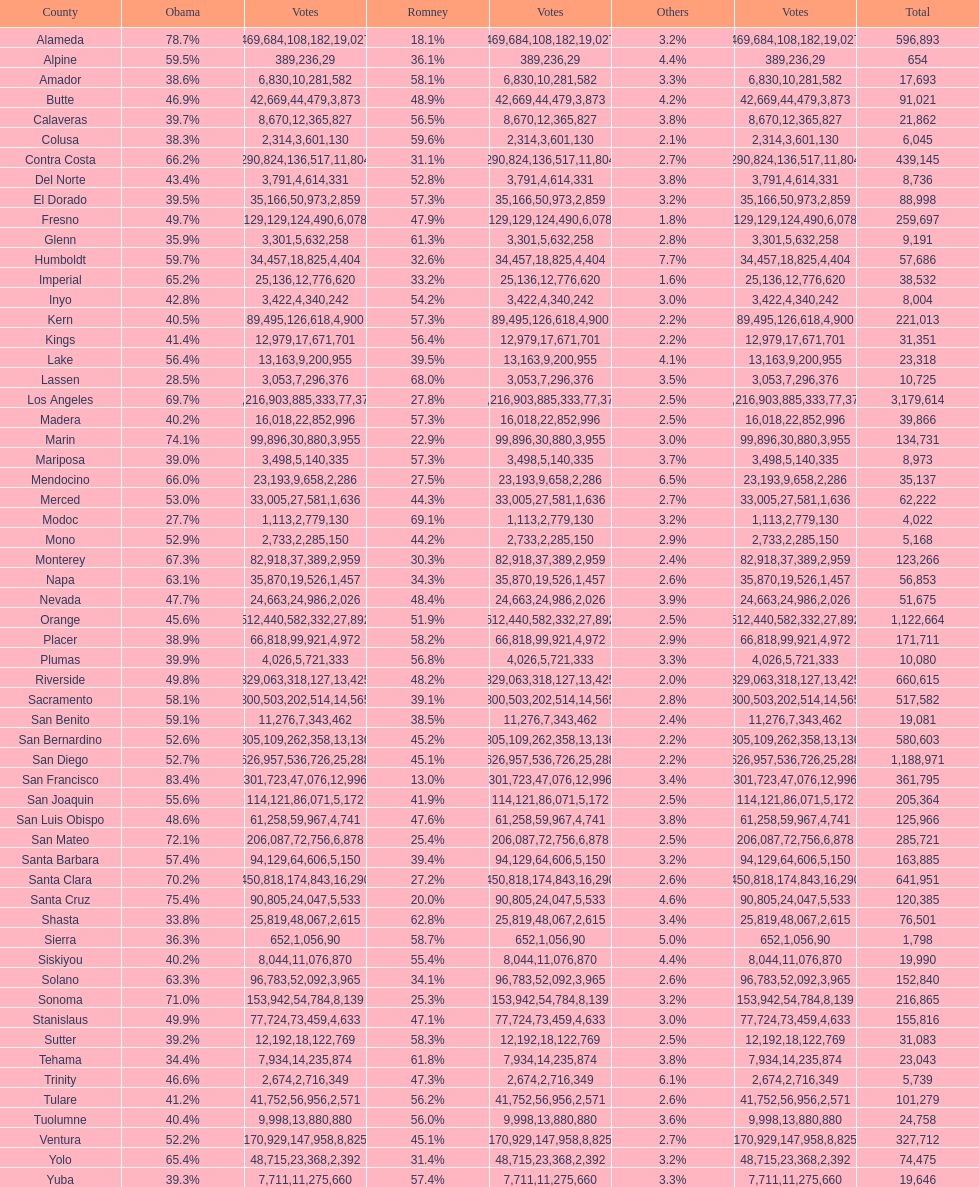What county is just before del norte on the list? Contra Costa. Would you be able to parse every entry in this table? {'header': ['County', 'Obama', 'Votes', 'Romney', 'Votes', 'Others', 'Votes', 'Total'], 'rows': [['Alameda', '78.7%', '469,684', '18.1%', '108,182', '3.2%', '19,027', '596,893'], ['Alpine', '59.5%', '389', '36.1%', '236', '4.4%', '29', '654'], ['Amador', '38.6%', '6,830', '58.1%', '10,281', '3.3%', '582', '17,693'], ['Butte', '46.9%', '42,669', '48.9%', '44,479', '4.2%', '3,873', '91,021'], ['Calaveras', '39.7%', '8,670', '56.5%', '12,365', '3.8%', '827', '21,862'], ['Colusa', '38.3%', '2,314', '59.6%', '3,601', '2.1%', '130', '6,045'], ['Contra Costa', '66.2%', '290,824', '31.1%', '136,517', '2.7%', '11,804', '439,145'], ['Del Norte', '43.4%', '3,791', '52.8%', '4,614', '3.8%', '331', '8,736'], ['El Dorado', '39.5%', '35,166', '57.3%', '50,973', '3.2%', '2,859', '88,998'], ['Fresno', '49.7%', '129,129', '47.9%', '124,490', '1.8%', '6,078', '259,697'], ['Glenn', '35.9%', '3,301', '61.3%', '5,632', '2.8%', '258', '9,191'], ['Humboldt', '59.7%', '34,457', '32.6%', '18,825', '7.7%', '4,404', '57,686'], ['Imperial', '65.2%', '25,136', '33.2%', '12,776', '1.6%', '620', '38,532'], ['Inyo', '42.8%', '3,422', '54.2%', '4,340', '3.0%', '242', '8,004'], ['Kern', '40.5%', '89,495', '57.3%', '126,618', '2.2%', '4,900', '221,013'], ['Kings', '41.4%', '12,979', '56.4%', '17,671', '2.2%', '701', '31,351'], ['Lake', '56.4%', '13,163', '39.5%', '9,200', '4.1%', '955', '23,318'], ['Lassen', '28.5%', '3,053', '68.0%', '7,296', '3.5%', '376', '10,725'], ['Los Angeles', '69.7%', '2,216,903', '27.8%', '885,333', '2.5%', '77,378', '3,179,614'], ['Madera', '40.2%', '16,018', '57.3%', '22,852', '2.5%', '996', '39,866'], ['Marin', '74.1%', '99,896', '22.9%', '30,880', '3.0%', '3,955', '134,731'], ['Mariposa', '39.0%', '3,498', '57.3%', '5,140', '3.7%', '335', '8,973'], ['Mendocino', '66.0%', '23,193', '27.5%', '9,658', '6.5%', '2,286', '35,137'], ['Merced', '53.0%', '33,005', '44.3%', '27,581', '2.7%', '1,636', '62,222'], ['Modoc', '27.7%', '1,113', '69.1%', '2,779', '3.2%', '130', '4,022'], ['Mono', '52.9%', '2,733', '44.2%', '2,285', '2.9%', '150', '5,168'], ['Monterey', '67.3%', '82,918', '30.3%', '37,389', '2.4%', '2,959', '123,266'], ['Napa', '63.1%', '35,870', '34.3%', '19,526', '2.6%', '1,457', '56,853'], ['Nevada', '47.7%', '24,663', '48.4%', '24,986', '3.9%', '2,026', '51,675'], ['Orange', '45.6%', '512,440', '51.9%', '582,332', '2.5%', '27,892', '1,122,664'], ['Placer', '38.9%', '66,818', '58.2%', '99,921', '2.9%', '4,972', '171,711'], ['Plumas', '39.9%', '4,026', '56.8%', '5,721', '3.3%', '333', '10,080'], ['Riverside', '49.8%', '329,063', '48.2%', '318,127', '2.0%', '13,425', '660,615'], ['Sacramento', '58.1%', '300,503', '39.1%', '202,514', '2.8%', '14,565', '517,582'], ['San Benito', '59.1%', '11,276', '38.5%', '7,343', '2.4%', '462', '19,081'], ['San Bernardino', '52.6%', '305,109', '45.2%', '262,358', '2.2%', '13,136', '580,603'], ['San Diego', '52.7%', '626,957', '45.1%', '536,726', '2.2%', '25,288', '1,188,971'], ['San Francisco', '83.4%', '301,723', '13.0%', '47,076', '3.4%', '12,996', '361,795'], ['San Joaquin', '55.6%', '114,121', '41.9%', '86,071', '2.5%', '5,172', '205,364'], ['San Luis Obispo', '48.6%', '61,258', '47.6%', '59,967', '3.8%', '4,741', '125,966'], ['San Mateo', '72.1%', '206,087', '25.4%', '72,756', '2.5%', '6,878', '285,721'], ['Santa Barbara', '57.4%', '94,129', '39.4%', '64,606', '3.2%', '5,150', '163,885'], ['Santa Clara', '70.2%', '450,818', '27.2%', '174,843', '2.6%', '16,290', '641,951'], ['Santa Cruz', '75.4%', '90,805', '20.0%', '24,047', '4.6%', '5,533', '120,385'], ['Shasta', '33.8%', '25,819', '62.8%', '48,067', '3.4%', '2,615', '76,501'], ['Sierra', '36.3%', '652', '58.7%', '1,056', '5.0%', '90', '1,798'], ['Siskiyou', '40.2%', '8,044', '55.4%', '11,076', '4.4%', '870', '19,990'], ['Solano', '63.3%', '96,783', '34.1%', '52,092', '2.6%', '3,965', '152,840'], ['Sonoma', '71.0%', '153,942', '25.3%', '54,784', '3.2%', '8,139', '216,865'], ['Stanislaus', '49.9%', '77,724', '47.1%', '73,459', '3.0%', '4,633', '155,816'], ['Sutter', '39.2%', '12,192', '58.3%', '18,122', '2.5%', '769', '31,083'], ['Tehama', '34.4%', '7,934', '61.8%', '14,235', '3.8%', '874', '23,043'], ['Trinity', '46.6%', '2,674', '47.3%', '2,716', '6.1%', '349', '5,739'], ['Tulare', '41.2%', '41,752', '56.2%', '56,956', '2.6%', '2,571', '101,279'], ['Tuolumne', '40.4%', '9,998', '56.0%', '13,880', '3.6%', '880', '24,758'], ['Ventura', '52.2%', '170,929', '45.1%', '147,958', '2.7%', '8,825', '327,712'], ['Yolo', '65.4%', '48,715', '31.4%', '23,368', '3.2%', '2,392', '74,475'], ['Yuba', '39.3%', '7,711', '57.4%', '11,275', '3.3%', '660', '19,646']]} 